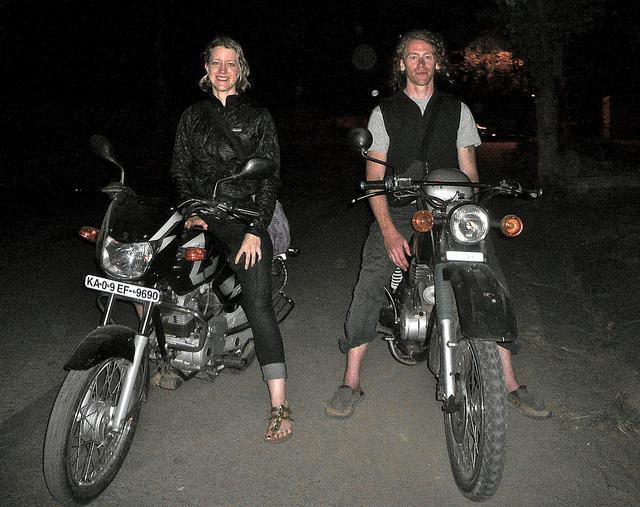How many people are there?
Give a very brief answer. 2. How many people are in the picture?
Give a very brief answer. 2. How many motorcycles are there?
Give a very brief answer. 2. How many horses are at the top of the hill?
Give a very brief answer. 0. 